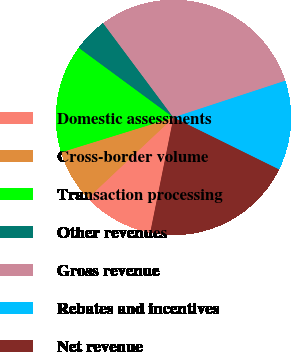Convert chart. <chart><loc_0><loc_0><loc_500><loc_500><pie_chart><fcel>Domestic assessments<fcel>Cross-border volume<fcel>Transaction processing<fcel>Other revenues<fcel>Gross revenue<fcel>Rebates and incentives<fcel>Net revenue<nl><fcel>9.8%<fcel>7.25%<fcel>14.88%<fcel>4.71%<fcel>30.14%<fcel>12.34%<fcel>20.88%<nl></chart> 